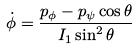<formula> <loc_0><loc_0><loc_500><loc_500>\dot { \phi } = \frac { p _ { \phi } - p _ { \psi } \cos \theta } { I _ { 1 } \sin ^ { 2 } \theta }</formula> 